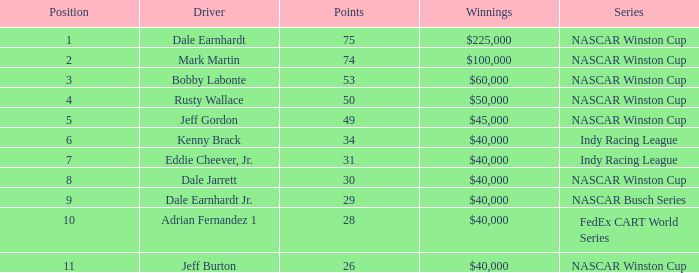In what position was the driver who won $60,000? 3.0. 